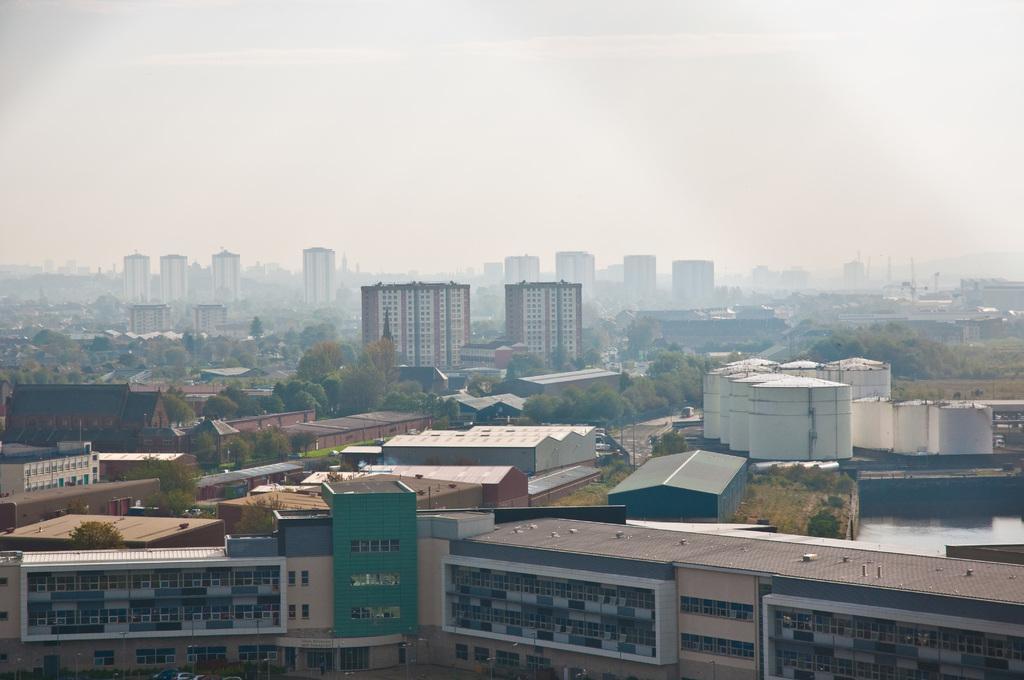How would you summarize this image in a sentence or two? In the image there are many buildings all over the place with trees all around it and above its sky. 